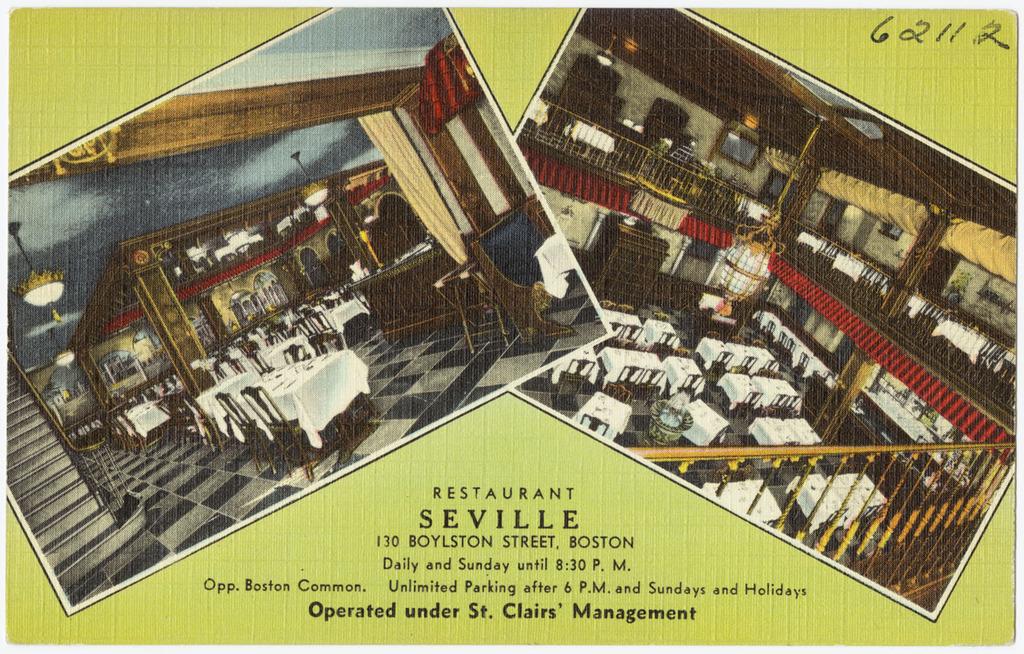Who is it operated under?
Your answer should be very brief. St. clairs' management. What is it?
Your answer should be very brief. Restaurant. 